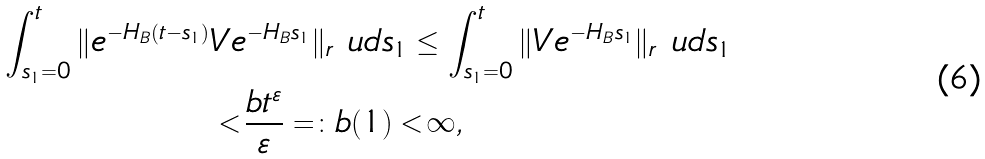<formula> <loc_0><loc_0><loc_500><loc_500>\int _ { s _ { 1 } = 0 } ^ { t } \| e ^ { - H _ { B } ( t - s _ { 1 } ) } & V e ^ { - H _ { B } s _ { 1 } } \| _ { r } \ u d s _ { 1 } \leq \int _ { s _ { 1 } = 0 } ^ { t } \| V e ^ { - H _ { B } s _ { 1 } } \| _ { r } \ u d s _ { 1 } \\ & < \frac { b t ^ { \varepsilon } } { \varepsilon } = \colon b ( 1 ) < \infty ,</formula> 